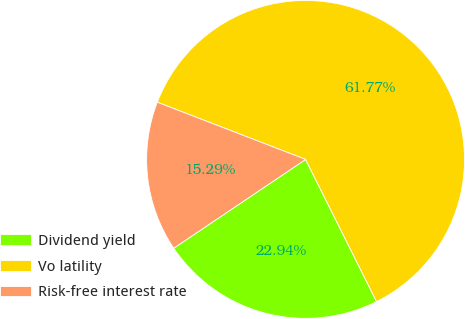Convert chart to OTSL. <chart><loc_0><loc_0><loc_500><loc_500><pie_chart><fcel>Dividend yield<fcel>Vo latility<fcel>Risk-free interest rate<nl><fcel>22.94%<fcel>61.77%<fcel>15.29%<nl></chart> 